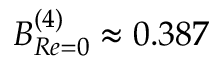Convert formula to latex. <formula><loc_0><loc_0><loc_500><loc_500>B _ { R e = 0 } ^ { ( 4 ) } \approx 0 . 3 8 7</formula> 